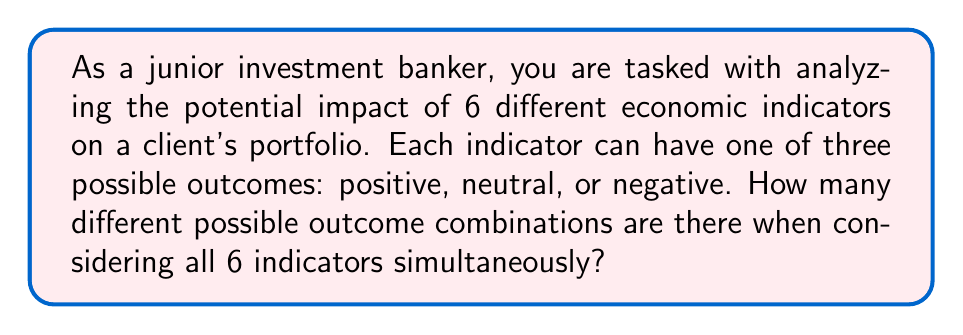Help me with this question. Let's approach this step-by-step:

1) We have 6 economic indicators, and each can have 3 possible outcomes.

2) This scenario is a perfect example of the Multiplication Principle in combinatorics. When we have a series of independent choices, where:
   - The first choice has $m_1$ options
   - The second choice has $m_2$ options
   - ...and so on until the $n$th choice with $m_n$ options

   Then the total number of possible outcomes is the product:

   $$ m_1 \times m_2 \times ... \times m_n $$

3) In our case, we have 6 choices (the 6 indicators), and each has 3 options. So we have:

   $$ 3 \times 3 \times 3 \times 3 \times 3 \times 3 $$

4) This can be written more concisely as:

   $$ 3^6 $$

5) Calculating this:
   $$ 3^6 = 3 \times 3 \times 3 \times 3 \times 3 \times 3 = 729 $$

Therefore, there are 729 different possible outcome combinations when analyzing these 6 economic indicators.
Answer: 729 